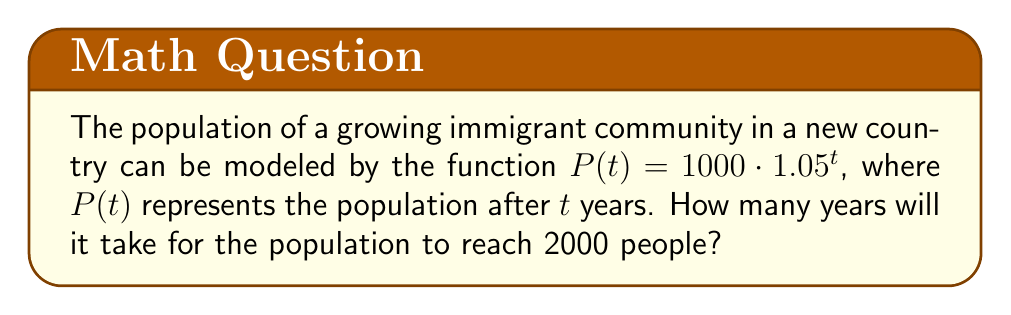Teach me how to tackle this problem. Let's approach this step-by-step:

1) We want to find $t$ when $P(t) = 2000$. So, we can set up the equation:

   $2000 = 1000 \cdot 1.05^t$

2) Divide both sides by 1000:

   $2 = 1.05^t$

3) To solve for $t$, we need to take the logarithm of both sides. We can use any base, but let's use the natural log (ln) for simplicity:

   $\ln(2) = \ln(1.05^t)$

4) Using the logarithm property $\ln(a^b) = b\ln(a)$, we get:

   $\ln(2) = t \cdot \ln(1.05)$

5) Now we can solve for $t$:

   $t = \frac{\ln(2)}{\ln(1.05)}$

6) Using a calculator:

   $t \approx 14.2067$

7) Since we're dealing with years, we need to round up to the next whole number.

Therefore, it will take 15 years for the population to reach 2000 people.
Answer: 15 years 